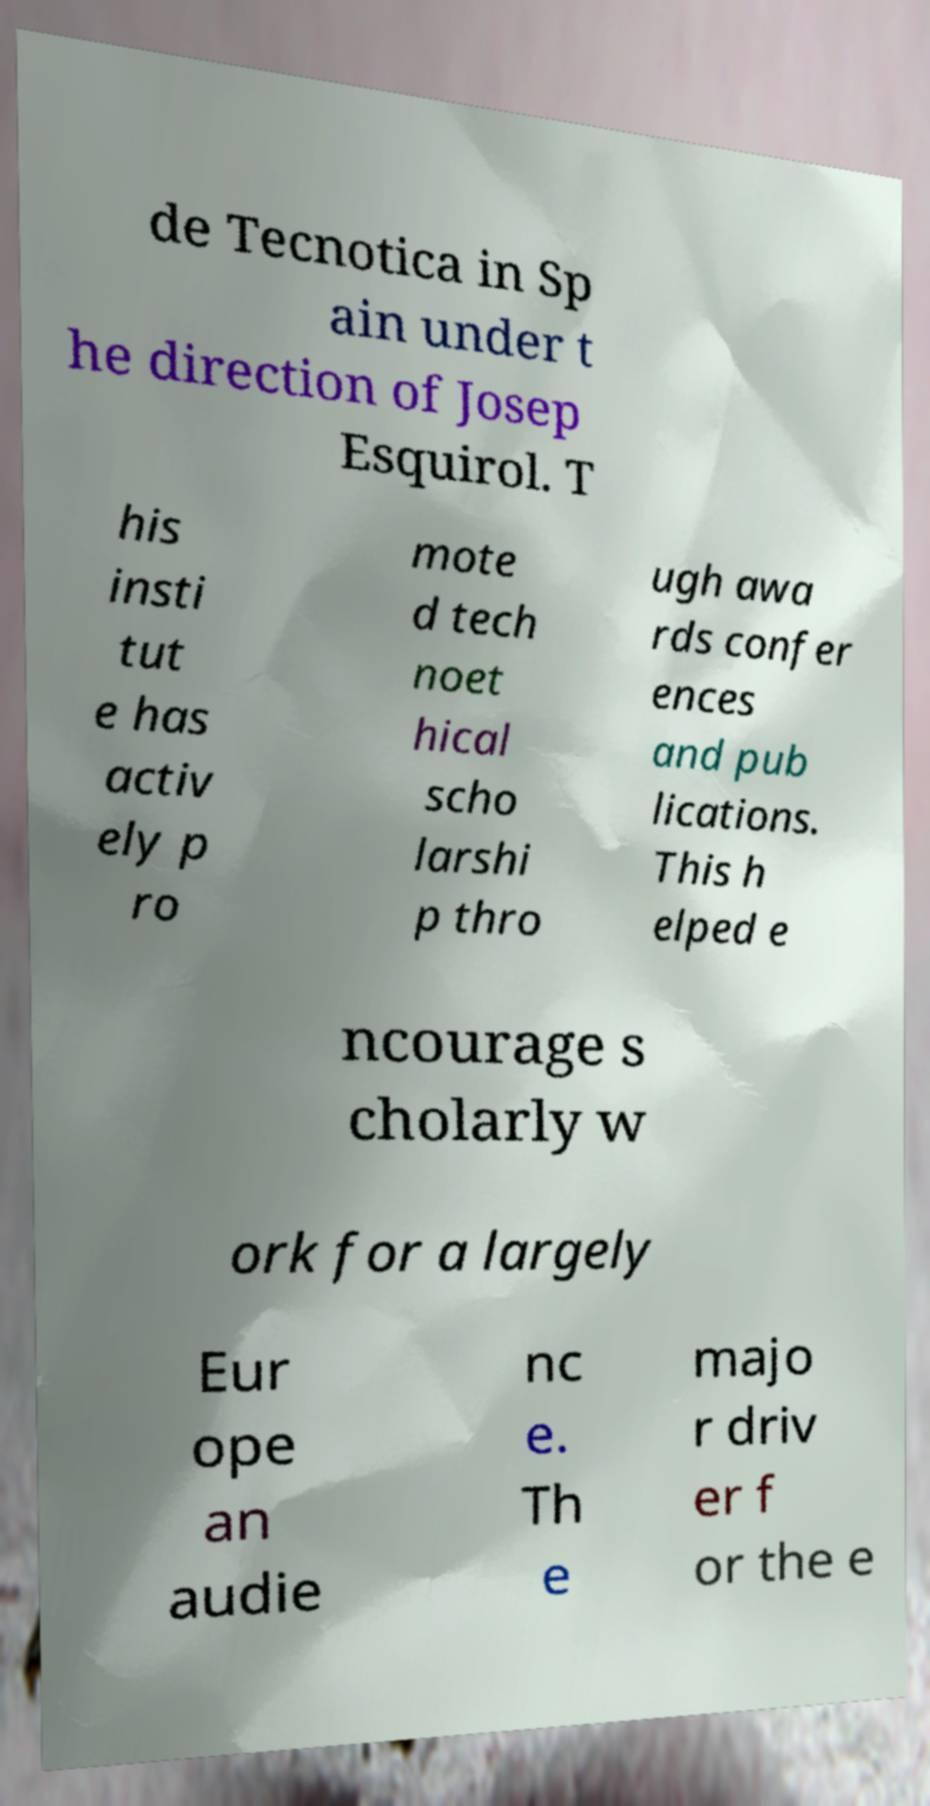Can you read and provide the text displayed in the image?This photo seems to have some interesting text. Can you extract and type it out for me? de Tecnotica in Sp ain under t he direction of Josep Esquirol. T his insti tut e has activ ely p ro mote d tech noet hical scho larshi p thro ugh awa rds confer ences and pub lications. This h elped e ncourage s cholarly w ork for a largely Eur ope an audie nc e. Th e majo r driv er f or the e 